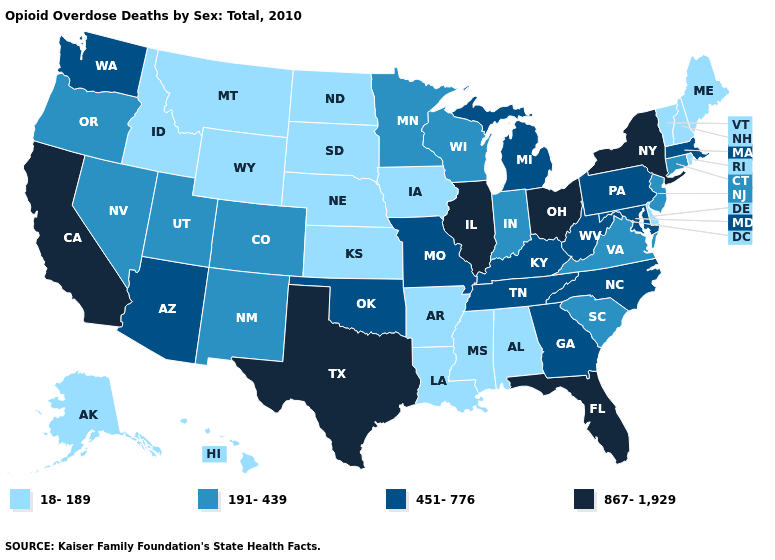Does Ohio have the same value as West Virginia?
Be succinct. No. Is the legend a continuous bar?
Give a very brief answer. No. Does Louisiana have the lowest value in the USA?
Write a very short answer. Yes. What is the lowest value in the USA?
Concise answer only. 18-189. Name the states that have a value in the range 451-776?
Give a very brief answer. Arizona, Georgia, Kentucky, Maryland, Massachusetts, Michigan, Missouri, North Carolina, Oklahoma, Pennsylvania, Tennessee, Washington, West Virginia. Does the first symbol in the legend represent the smallest category?
Quick response, please. Yes. Does the map have missing data?
Be succinct. No. Among the states that border Utah , which have the highest value?
Give a very brief answer. Arizona. Does the map have missing data?
Answer briefly. No. Does Ohio have the same value as Utah?
Give a very brief answer. No. Among the states that border Arkansas , which have the lowest value?
Concise answer only. Louisiana, Mississippi. Which states hav the highest value in the MidWest?
Give a very brief answer. Illinois, Ohio. Does North Dakota have the lowest value in the USA?
Answer briefly. Yes. What is the highest value in states that border South Dakota?
Keep it brief. 191-439. What is the lowest value in the MidWest?
Write a very short answer. 18-189. 